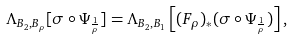<formula> <loc_0><loc_0><loc_500><loc_500>\Lambda _ { B _ { 2 } , B _ { \rho } } [ \sigma \circ \Psi _ { \frac { 1 } { \rho } } ] = \Lambda _ { B _ { 2 } , B _ { 1 } } \left [ ( F _ { \rho } ) _ { * } ( \sigma \circ \Psi _ { \frac { 1 } { \rho } } ) \right ] ,</formula> 